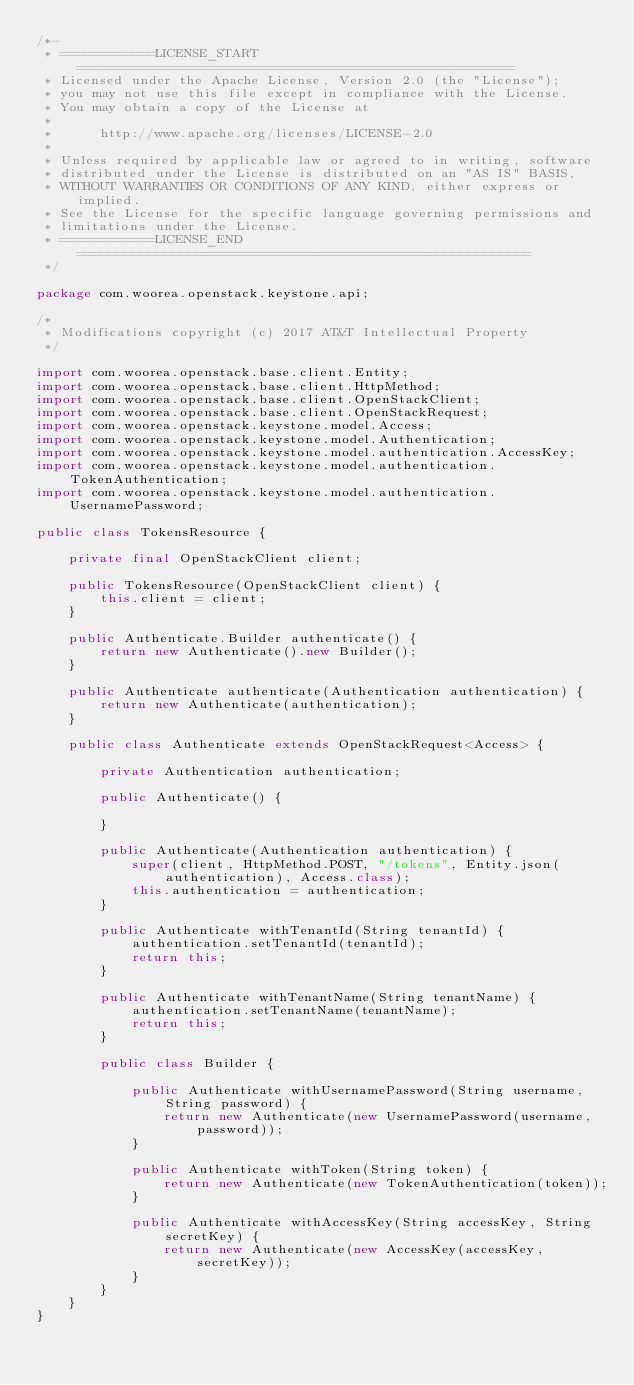<code> <loc_0><loc_0><loc_500><loc_500><_Java_>/*-
 * ============LICENSE_START=======================================================
 * Licensed under the Apache License, Version 2.0 (the "License");
 * you may not use this file except in compliance with the License.
 * You may obtain a copy of the License at
 *
 *      http://www.apache.org/licenses/LICENSE-2.0
 *
 * Unless required by applicable law or agreed to in writing, software
 * distributed under the License is distributed on an "AS IS" BASIS,
 * WITHOUT WARRANTIES OR CONDITIONS OF ANY KIND, either express or implied.
 * See the License for the specific language governing permissions and
 * limitations under the License.
 * ============LICENSE_END=========================================================
 */

package com.woorea.openstack.keystone.api;

/*
 * Modifications copyright (c) 2017 AT&T Intellectual Property
 */

import com.woorea.openstack.base.client.Entity;
import com.woorea.openstack.base.client.HttpMethod;
import com.woorea.openstack.base.client.OpenStackClient;
import com.woorea.openstack.base.client.OpenStackRequest;
import com.woorea.openstack.keystone.model.Access;
import com.woorea.openstack.keystone.model.Authentication;
import com.woorea.openstack.keystone.model.authentication.AccessKey;
import com.woorea.openstack.keystone.model.authentication.TokenAuthentication;
import com.woorea.openstack.keystone.model.authentication.UsernamePassword;

public class TokensResource {

    private final OpenStackClient client;

    public TokensResource(OpenStackClient client) {
        this.client = client;
    }

    public Authenticate.Builder authenticate() {
        return new Authenticate().new Builder();
    }

    public Authenticate authenticate(Authentication authentication) {
        return new Authenticate(authentication);
    }

    public class Authenticate extends OpenStackRequest<Access> {

        private Authentication authentication;

        public Authenticate() {

        }

        public Authenticate(Authentication authentication) {
            super(client, HttpMethod.POST, "/tokens", Entity.json(authentication), Access.class);
            this.authentication = authentication;
        }

        public Authenticate withTenantId(String tenantId) {
            authentication.setTenantId(tenantId);
            return this;
        }

        public Authenticate withTenantName(String tenantName) {
            authentication.setTenantName(tenantName);
            return this;
        }

        public class Builder {

            public Authenticate withUsernamePassword(String username, String password) {
                return new Authenticate(new UsernamePassword(username, password));
            }

            public Authenticate withToken(String token) {
                return new Authenticate(new TokenAuthentication(token));
            }

            public Authenticate withAccessKey(String accessKey, String secretKey) {
                return new Authenticate(new AccessKey(accessKey, secretKey));
            }
        }
    }
}
</code> 